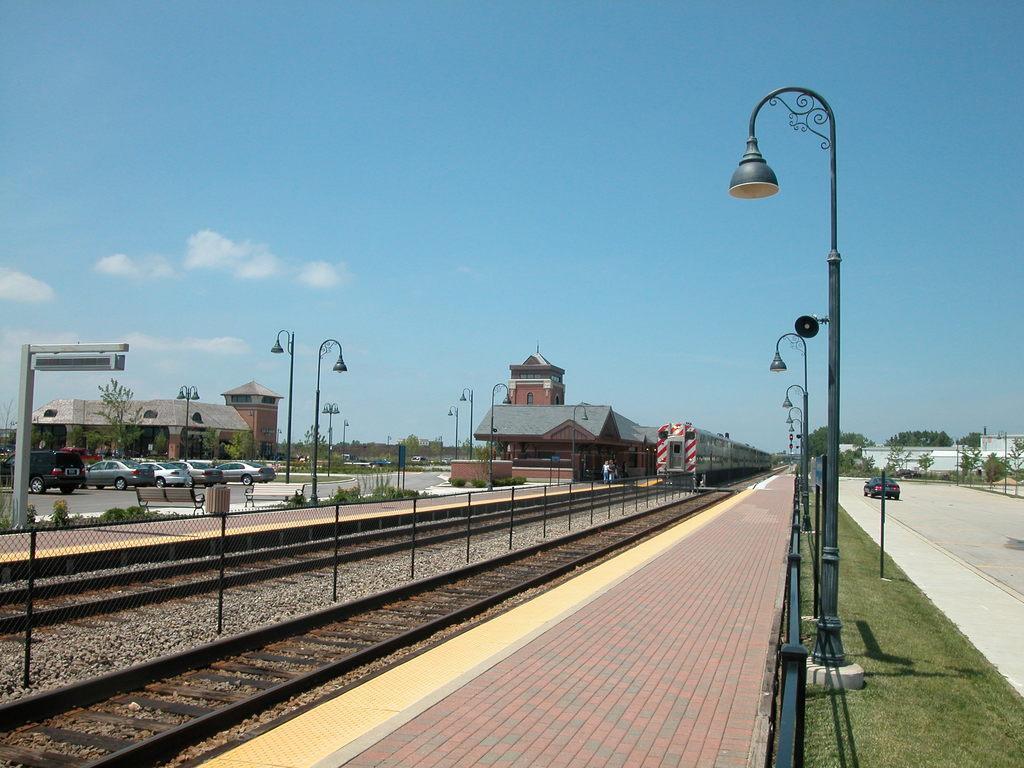Can you describe this image briefly? In this picture I can see there is a railway track at left side and there is a fence, beside the fence there is another train track and there are two platforms and there are trees, poles with lights and there are few buildings at left and right. There is a car moving on the road and the sky is clear. 